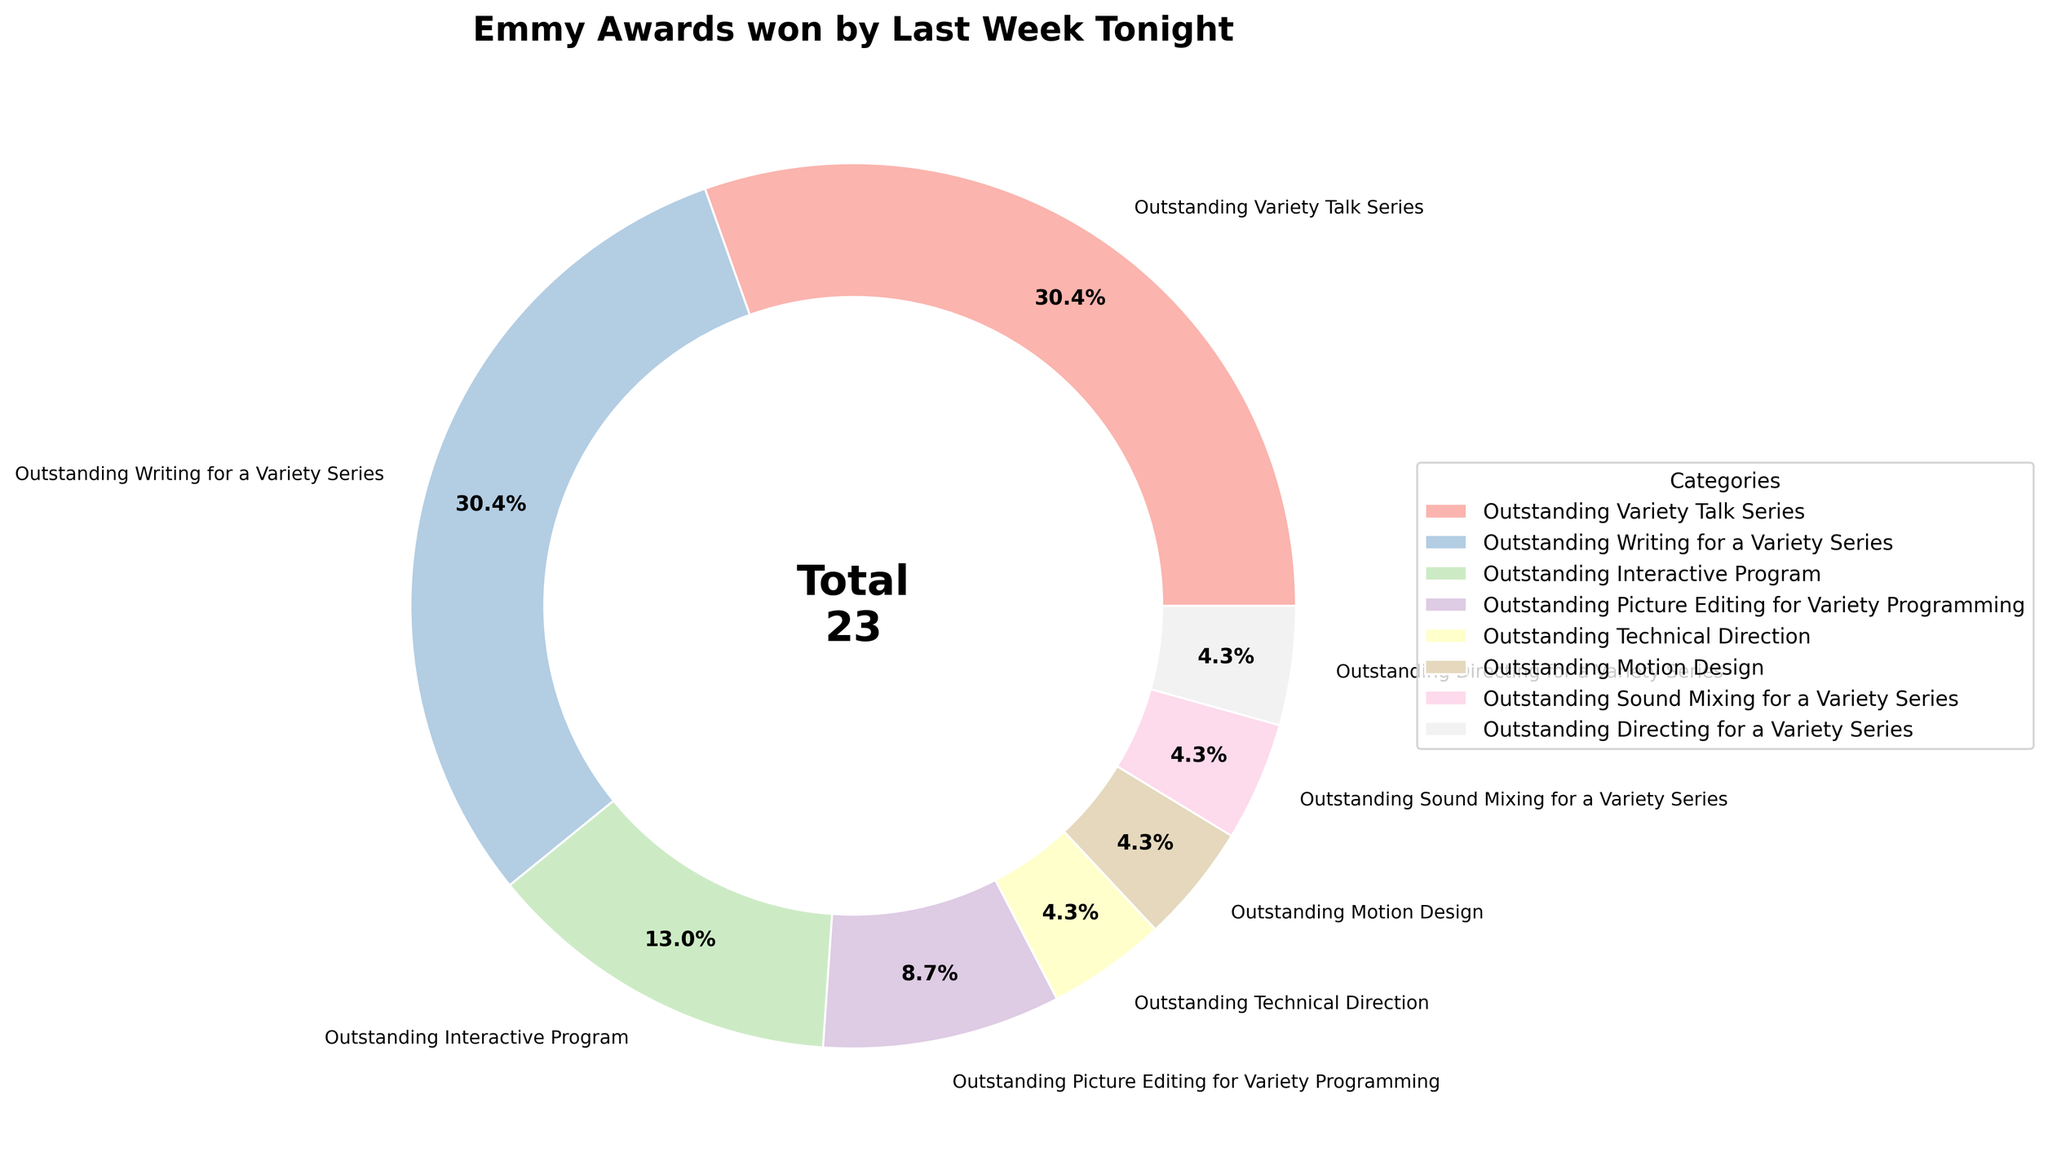How many total Emmy Awards has Last Week Tonight won in categories that are not related to writing or talk series? First, identify the categories related to writing and talk series, which are "Outstanding Variety Talk Series" and "Outstanding Writing for a Variety Series." The sum of Emmys in these categories is 7 + 7 = 14. The total number of Emmys across all categories is stated in the center of the pie chart as 23. Subtract the Emmys for writing and talk series categories from the total: 23 - 14 = 9.
Answer: 9 Which category has won the second-highest number of Emmy Awards? "Outstanding Variety Talk Series" and "Outstanding Writing for a Variety Series" both have 7 Emmys, which are the highest. The second-highest number of Emmys is 3, which is in the category "Outstanding Interactive Program."
Answer: Outstanding Interactive Program What percentage of the total Emmy Awards is for "Outstanding Sound Mixing for a Variety Series"? The number of Emmys in this category is 1. The total number of Emmys is 23. To find the percentage, use the formula (Emmys in category / total Emmys) * 100: (1 / 23) * 100 ≈ 4.3%.
Answer: 4.3% Which categories have won the same number of Emmy Awards? The categories "Outstanding Variety Talk Series" and "Outstanding Writing for a Variety Series" both have 7 Emmys each.
Answer: Outstanding Variety Talk Series and Outstanding Writing for a Variety Series How does the number of Emmy Awards for "Outstanding Technical Direction" compare to the "Outstanding Motion Design"? Both categories each have 1 Emmy Award. Thus, they are equal.
Answer: They are equal What is the proportion of Emmys won in "Outstanding Picture Editing for Variety Programming" to the total Emmys? The number of Emmys in "Outstanding Picture Editing for Variety Programming" is 2. The total number of Emmys is 23. The proportion is calculated as the number of Emmys in the category divided by the total: 2 / 23 ≈ 0.087 or about 8.7%.
Answer: 8.7% What is the combined percentage of "Outstanding Interactive Program" and "Outstanding Sound Mixing for a Variety Series"? "Outstanding Interactive Program" has 3 Emmys and "Outstanding Sound Mixing for a Variety Series" has 1 Emmy. The combined number of Emmys is 3 + 1 = 4. The total number of Emmys is 23. To find the combined percentage, use the formula (combined Emmys / total Emmys) * 100: (4 / 23) * 100 ≈ 17.4%.
Answer: 17.4% If another Emmy Award was added to "Outstanding Technical Direction," what would the new percentage for this category be? Currently, the "Outstanding Technical Direction" category has 1 Emmy and the total is 23 Emmys. If 1 more Emmy is added, the total Emmys become 24 and this category would have 2 Emmys. The new percentage would be (2 / 24) * 100 = 8.3%.
Answer: 8.3% 